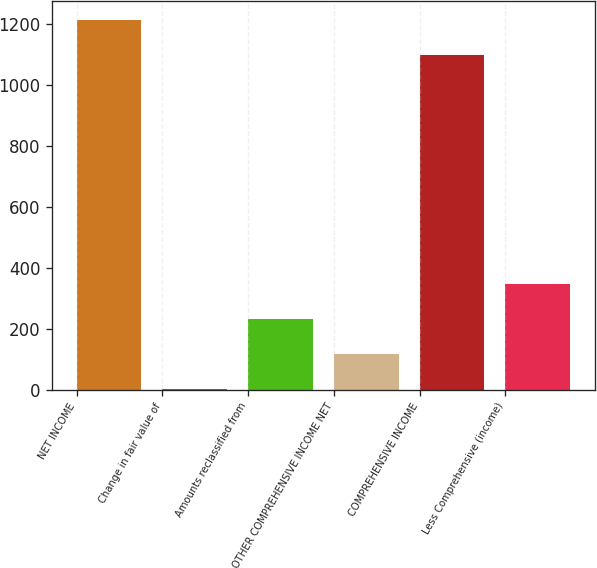<chart> <loc_0><loc_0><loc_500><loc_500><bar_chart><fcel>NET INCOME<fcel>Change in fair value of<fcel>Amounts reclassified from<fcel>OTHER COMPREHENSIVE INCOME NET<fcel>COMPREHENSIVE INCOME<fcel>Less Comprehensive (income)<nl><fcel>1214.1<fcel>1<fcel>231.2<fcel>116.1<fcel>1099<fcel>346.3<nl></chart> 